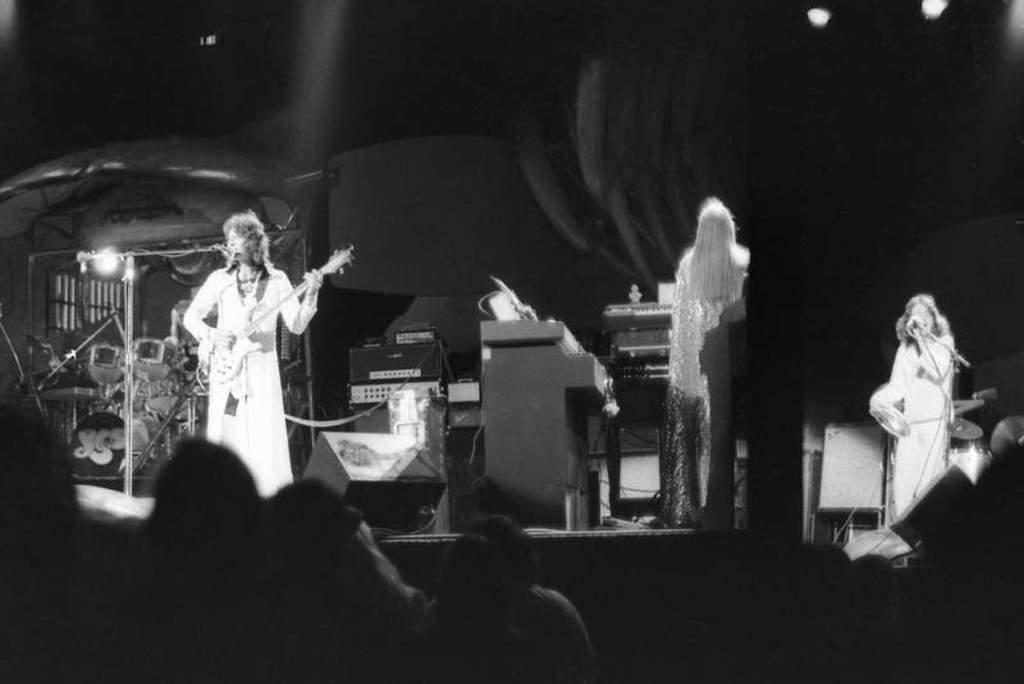Could you give a brief overview of what you see in this image? This is a black and white image and here we can see people and some are holding objects and we can see mic stands. In the background, there are musical instruments and we can see lights. 